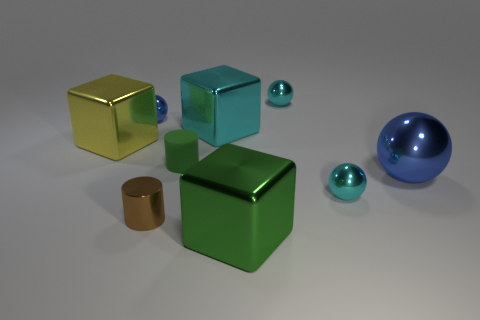Are there any matte objects?
Ensure brevity in your answer.  Yes. There is a green thing behind the small brown thing; is it the same size as the blue ball that is behind the big cyan metallic object?
Your answer should be compact. Yes. The small object that is behind the big blue ball and in front of the big cyan metallic object is made of what material?
Keep it short and to the point. Rubber. What number of large metallic cubes are in front of the rubber cylinder?
Give a very brief answer. 1. The tiny cylinder that is made of the same material as the green cube is what color?
Your response must be concise. Brown. Does the yellow object have the same shape as the tiny blue thing?
Make the answer very short. No. How many cyan metal spheres are in front of the tiny blue metal thing and behind the small rubber cylinder?
Make the answer very short. 0. How many matte objects are either tiny blue spheres or yellow balls?
Provide a succinct answer. 0. There is a green object in front of the cyan metal sphere that is in front of the small blue shiny object; what size is it?
Keep it short and to the point. Large. There is a thing that is the same color as the big sphere; what is it made of?
Give a very brief answer. Metal. 